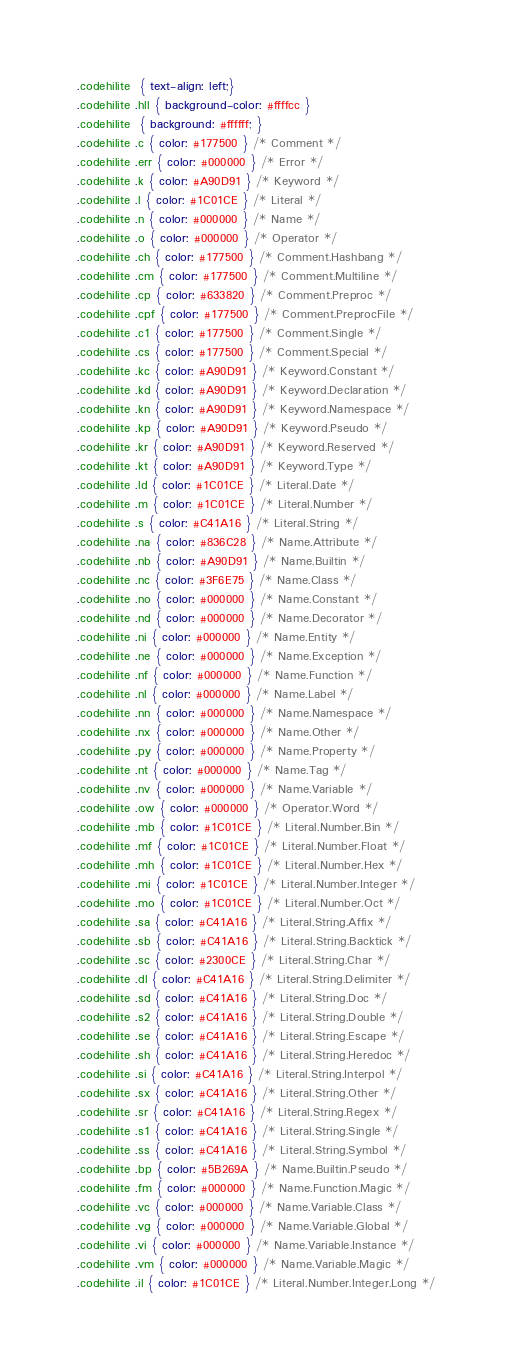Convert code to text. <code><loc_0><loc_0><loc_500><loc_500><_CSS_>.codehilite  { text-align: left;}
.codehilite .hll { background-color: #ffffcc }
.codehilite  { background: #ffffff; }
.codehilite .c { color: #177500 } /* Comment */
.codehilite .err { color: #000000 } /* Error */
.codehilite .k { color: #A90D91 } /* Keyword */
.codehilite .l { color: #1C01CE } /* Literal */
.codehilite .n { color: #000000 } /* Name */
.codehilite .o { color: #000000 } /* Operator */
.codehilite .ch { color: #177500 } /* Comment.Hashbang */
.codehilite .cm { color: #177500 } /* Comment.Multiline */
.codehilite .cp { color: #633820 } /* Comment.Preproc */
.codehilite .cpf { color: #177500 } /* Comment.PreprocFile */
.codehilite .c1 { color: #177500 } /* Comment.Single */
.codehilite .cs { color: #177500 } /* Comment.Special */
.codehilite .kc { color: #A90D91 } /* Keyword.Constant */
.codehilite .kd { color: #A90D91 } /* Keyword.Declaration */
.codehilite .kn { color: #A90D91 } /* Keyword.Namespace */
.codehilite .kp { color: #A90D91 } /* Keyword.Pseudo */
.codehilite .kr { color: #A90D91 } /* Keyword.Reserved */
.codehilite .kt { color: #A90D91 } /* Keyword.Type */
.codehilite .ld { color: #1C01CE } /* Literal.Date */
.codehilite .m { color: #1C01CE } /* Literal.Number */
.codehilite .s { color: #C41A16 } /* Literal.String */
.codehilite .na { color: #836C28 } /* Name.Attribute */
.codehilite .nb { color: #A90D91 } /* Name.Builtin */
.codehilite .nc { color: #3F6E75 } /* Name.Class */
.codehilite .no { color: #000000 } /* Name.Constant */
.codehilite .nd { color: #000000 } /* Name.Decorator */
.codehilite .ni { color: #000000 } /* Name.Entity */
.codehilite .ne { color: #000000 } /* Name.Exception */
.codehilite .nf { color: #000000 } /* Name.Function */
.codehilite .nl { color: #000000 } /* Name.Label */
.codehilite .nn { color: #000000 } /* Name.Namespace */
.codehilite .nx { color: #000000 } /* Name.Other */
.codehilite .py { color: #000000 } /* Name.Property */
.codehilite .nt { color: #000000 } /* Name.Tag */
.codehilite .nv { color: #000000 } /* Name.Variable */
.codehilite .ow { color: #000000 } /* Operator.Word */
.codehilite .mb { color: #1C01CE } /* Literal.Number.Bin */
.codehilite .mf { color: #1C01CE } /* Literal.Number.Float */
.codehilite .mh { color: #1C01CE } /* Literal.Number.Hex */
.codehilite .mi { color: #1C01CE } /* Literal.Number.Integer */
.codehilite .mo { color: #1C01CE } /* Literal.Number.Oct */
.codehilite .sa { color: #C41A16 } /* Literal.String.Affix */
.codehilite .sb { color: #C41A16 } /* Literal.String.Backtick */
.codehilite .sc { color: #2300CE } /* Literal.String.Char */
.codehilite .dl { color: #C41A16 } /* Literal.String.Delimiter */
.codehilite .sd { color: #C41A16 } /* Literal.String.Doc */
.codehilite .s2 { color: #C41A16 } /* Literal.String.Double */
.codehilite .se { color: #C41A16 } /* Literal.String.Escape */
.codehilite .sh { color: #C41A16 } /* Literal.String.Heredoc */
.codehilite .si { color: #C41A16 } /* Literal.String.Interpol */
.codehilite .sx { color: #C41A16 } /* Literal.String.Other */
.codehilite .sr { color: #C41A16 } /* Literal.String.Regex */
.codehilite .s1 { color: #C41A16 } /* Literal.String.Single */
.codehilite .ss { color: #C41A16 } /* Literal.String.Symbol */
.codehilite .bp { color: #5B269A } /* Name.Builtin.Pseudo */
.codehilite .fm { color: #000000 } /* Name.Function.Magic */
.codehilite .vc { color: #000000 } /* Name.Variable.Class */
.codehilite .vg { color: #000000 } /* Name.Variable.Global */
.codehilite .vi { color: #000000 } /* Name.Variable.Instance */
.codehilite .vm { color: #000000 } /* Name.Variable.Magic */
.codehilite .il { color: #1C01CE } /* Literal.Number.Integer.Long */
</code> 